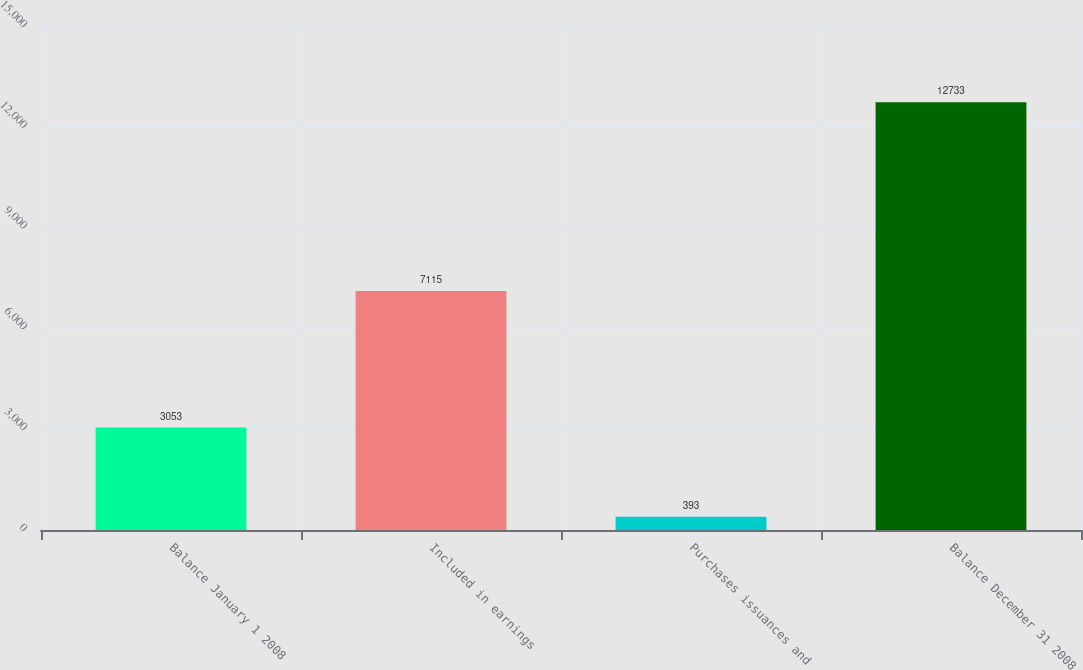Convert chart to OTSL. <chart><loc_0><loc_0><loc_500><loc_500><bar_chart><fcel>Balance January 1 2008<fcel>Included in earnings<fcel>Purchases issuances and<fcel>Balance December 31 2008<nl><fcel>3053<fcel>7115<fcel>393<fcel>12733<nl></chart> 